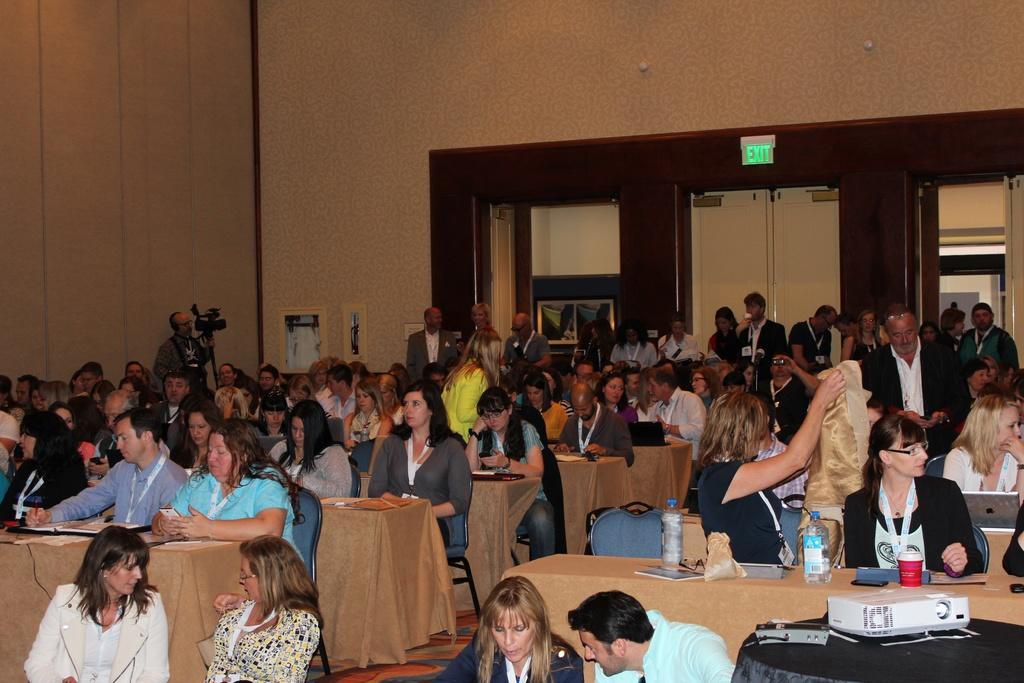Can you describe this image briefly? There is a room. There is a group of people. They are sitting on a chairs. There is a table. There is a glass,bottle,wire on a table. We can see in background wall,door and exit board. 